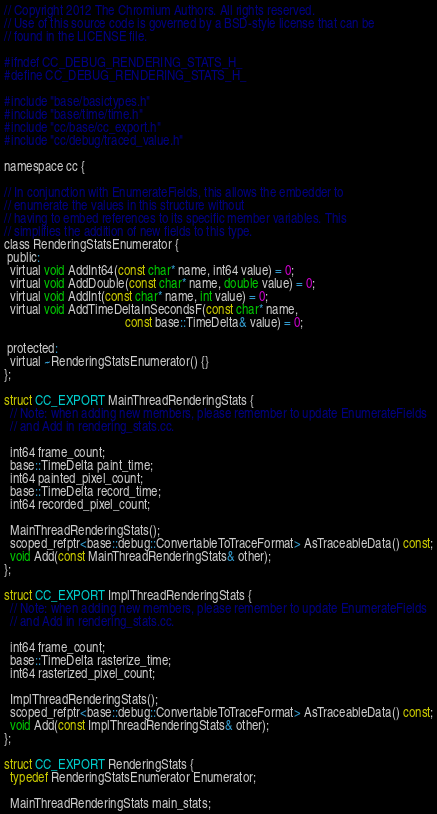Convert code to text. <code><loc_0><loc_0><loc_500><loc_500><_C_>// Copyright 2012 The Chromium Authors. All rights reserved.
// Use of this source code is governed by a BSD-style license that can be
// found in the LICENSE file.

#ifndef CC_DEBUG_RENDERING_STATS_H_
#define CC_DEBUG_RENDERING_STATS_H_

#include "base/basictypes.h"
#include "base/time/time.h"
#include "cc/base/cc_export.h"
#include "cc/debug/traced_value.h"

namespace cc {

// In conjunction with EnumerateFields, this allows the embedder to
// enumerate the values in this structure without
// having to embed references to its specific member variables. This
// simplifies the addition of new fields to this type.
class RenderingStatsEnumerator {
 public:
  virtual void AddInt64(const char* name, int64 value) = 0;
  virtual void AddDouble(const char* name, double value) = 0;
  virtual void AddInt(const char* name, int value) = 0;
  virtual void AddTimeDeltaInSecondsF(const char* name,
                                      const base::TimeDelta& value) = 0;

 protected:
  virtual ~RenderingStatsEnumerator() {}
};

struct CC_EXPORT MainThreadRenderingStats {
  // Note: when adding new members, please remember to update EnumerateFields
  // and Add in rendering_stats.cc.

  int64 frame_count;
  base::TimeDelta paint_time;
  int64 painted_pixel_count;
  base::TimeDelta record_time;
  int64 recorded_pixel_count;

  MainThreadRenderingStats();
  scoped_refptr<base::debug::ConvertableToTraceFormat> AsTraceableData() const;
  void Add(const MainThreadRenderingStats& other);
};

struct CC_EXPORT ImplThreadRenderingStats {
  // Note: when adding new members, please remember to update EnumerateFields
  // and Add in rendering_stats.cc.

  int64 frame_count;
  base::TimeDelta rasterize_time;
  int64 rasterized_pixel_count;

  ImplThreadRenderingStats();
  scoped_refptr<base::debug::ConvertableToTraceFormat> AsTraceableData() const;
  void Add(const ImplThreadRenderingStats& other);
};

struct CC_EXPORT RenderingStats {
  typedef RenderingStatsEnumerator Enumerator;

  MainThreadRenderingStats main_stats;</code> 